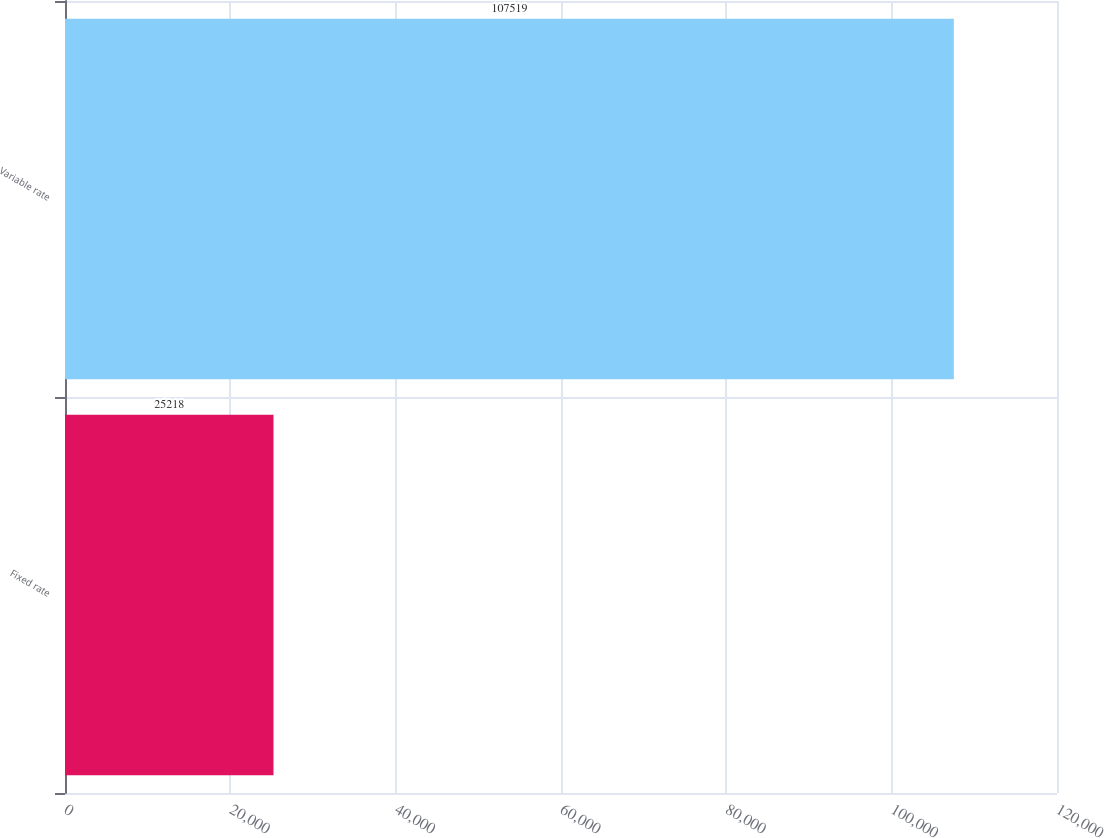Convert chart. <chart><loc_0><loc_0><loc_500><loc_500><bar_chart><fcel>Fixed rate<fcel>Variable rate<nl><fcel>25218<fcel>107519<nl></chart> 